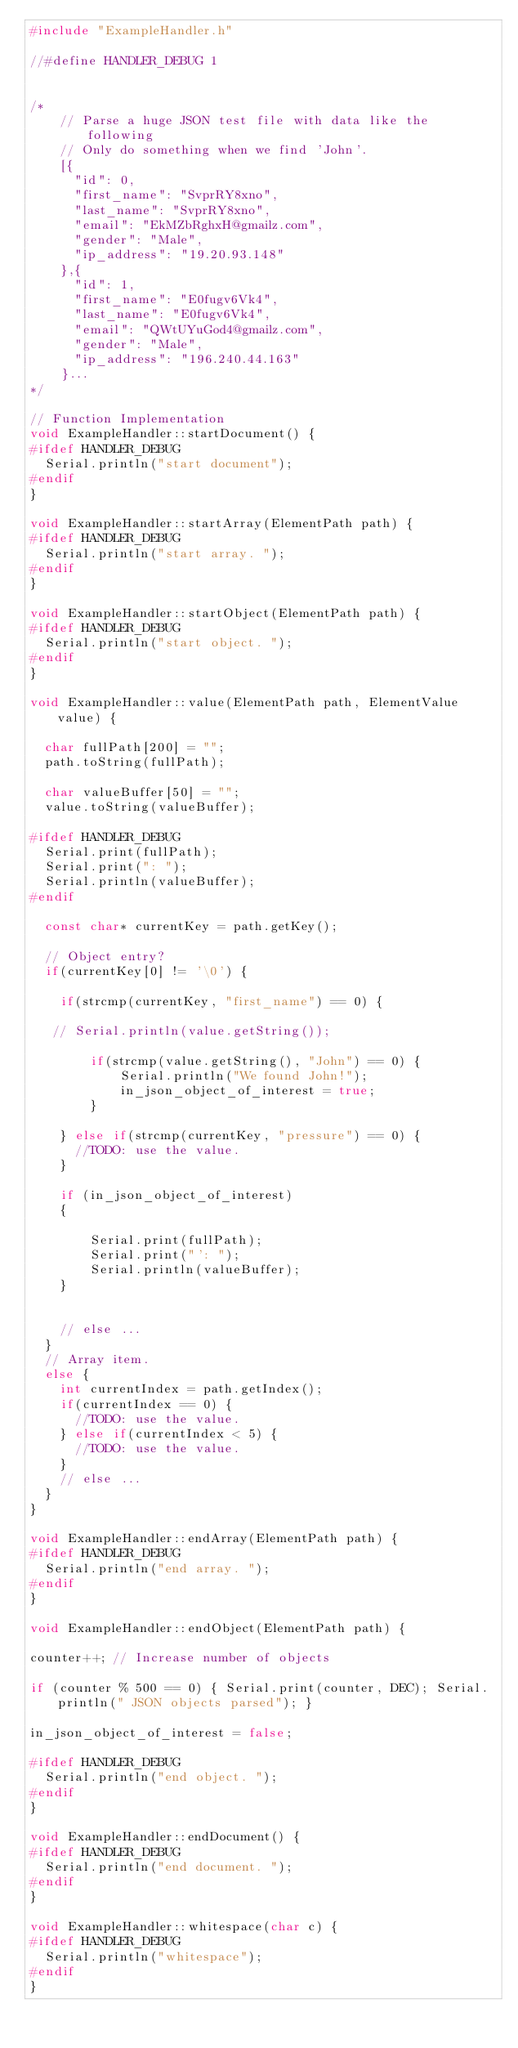Convert code to text. <code><loc_0><loc_0><loc_500><loc_500><_C++_>#include "ExampleHandler.h"

//#define HANDLER_DEBUG 1


/*
	// Parse a huge JSON test file with data like the following
	// Only do something when we find 'John'.
	[{
	  "id": 0,	
	  "first_name": "SvprRY8xno",
	  "last_name": "SvprRY8xno",
	  "email": "EkMZbRghxH@gmailz.com",
	  "gender": "Male",
	  "ip_address": "19.20.93.148" 
	},{
	  "id": 1,	
	  "first_name": "E0fugv6Vk4",
	  "last_name": "E0fugv6Vk4",
	  "email": "QWtUYuGod4@gmailz.com",
	  "gender": "Male",
	  "ip_address": "196.240.44.163" 
	}...
*/

// Function Implementation
void ExampleHandler::startDocument() {
#ifdef HANDLER_DEBUG	
  Serial.println("start document");
#endif  
}

void ExampleHandler::startArray(ElementPath path) {
#ifdef HANDLER_DEBUG	
  Serial.println("start array. ");
#endif  
}

void ExampleHandler::startObject(ElementPath path) {
#ifdef HANDLER_DEBUG	
  Serial.println("start object. ");
#endif  
}

void ExampleHandler::value(ElementPath path, ElementValue value) {
	
  char fullPath[200] = "";	
  path.toString(fullPath);
  
  char valueBuffer[50] = "";  
  value.toString(valueBuffer);
  
#ifdef HANDLER_DEBUG	
  Serial.print(fullPath);
  Serial.print(": ");
  Serial.println(valueBuffer);
#endif    
  
  const char* currentKey = path.getKey();
  
  // Object entry?
  if(currentKey[0] != '\0') {
	  
    if(strcmp(currentKey, "first_name") == 0) {		

   // Serial.println(value.getString());      
	
		if(strcmp(value.getString(), "John") == 0) {
			Serial.println("We found John!");
			in_json_object_of_interest = true;
		}			
      
    } else if(strcmp(currentKey, "pressure") == 0) {
      //TODO: use the value.
    }
	
  	if (in_json_object_of_interest)
  	{
  
  		Serial.print(fullPath);
  		Serial.print("': ");
  		Serial.println(valueBuffer);	
  	}
	
	
    // else ... 
  } 
  // Array item.
  else {
    int currentIndex = path.getIndex();
    if(currentIndex == 0) {
      //TODO: use the value.
    } else if(currentIndex < 5) {
      //TODO: use the value.
    }
    // else ... 
  }
}

void ExampleHandler::endArray(ElementPath path) {
#ifdef HANDLER_DEBUG	
  Serial.println("end array. ");
#endif  
}

void ExampleHandler::endObject(ElementPath path) {
	
counter++; // Increase number of objects

if (counter % 500 == 0) { Serial.print(counter, DEC); Serial.println(" JSON objects parsed"); }

in_json_object_of_interest = false;
	
#ifdef HANDLER_DEBUG	
  Serial.println("end object. ");
#endif  
}

void ExampleHandler::endDocument() {
#ifdef HANDLER_DEBUG	
  Serial.println("end document. ");
#endif  
}

void ExampleHandler::whitespace(char c) {
#ifdef HANDLER_DEBUG	
  Serial.println("whitespace");
#endif  
}</code> 